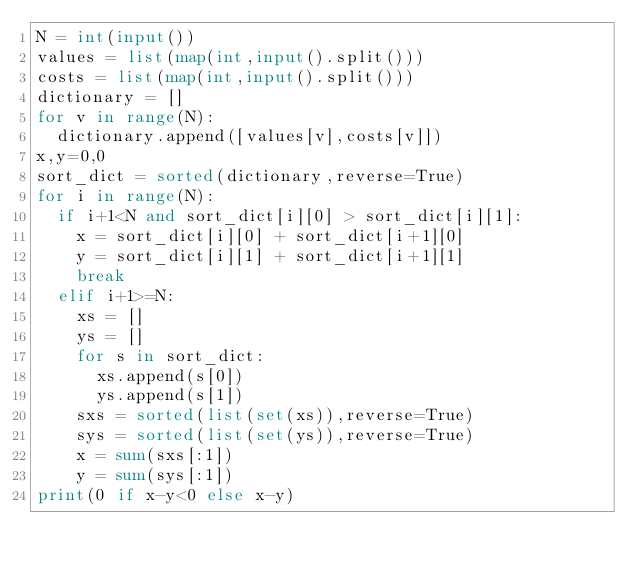<code> <loc_0><loc_0><loc_500><loc_500><_Python_>N = int(input())
values = list(map(int,input().split()))
costs = list(map(int,input().split()))
dictionary = []
for v in range(N):
  dictionary.append([values[v],costs[v]])
x,y=0,0
sort_dict = sorted(dictionary,reverse=True)
for i in range(N):
  if i+1<N and sort_dict[i][0] > sort_dict[i][1]:
    x = sort_dict[i][0] + sort_dict[i+1][0]
    y = sort_dict[i][1] + sort_dict[i+1][1]
    break
  elif i+1>=N:
    xs = []
    ys = []
    for s in sort_dict:
      xs.append(s[0])
      ys.append(s[1])
    sxs = sorted(list(set(xs)),reverse=True)
    sys = sorted(list(set(ys)),reverse=True)
    x = sum(sxs[:1])
    y = sum(sys[:1])
print(0 if x-y<0 else x-y)
 </code> 